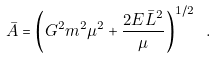<formula> <loc_0><loc_0><loc_500><loc_500>\bar { A } = \left ( G ^ { 2 } m ^ { 2 } \mu ^ { 2 } + \frac { 2 E \bar { L } ^ { 2 } } { \mu } \right ) ^ { 1 / 2 } \ .</formula> 